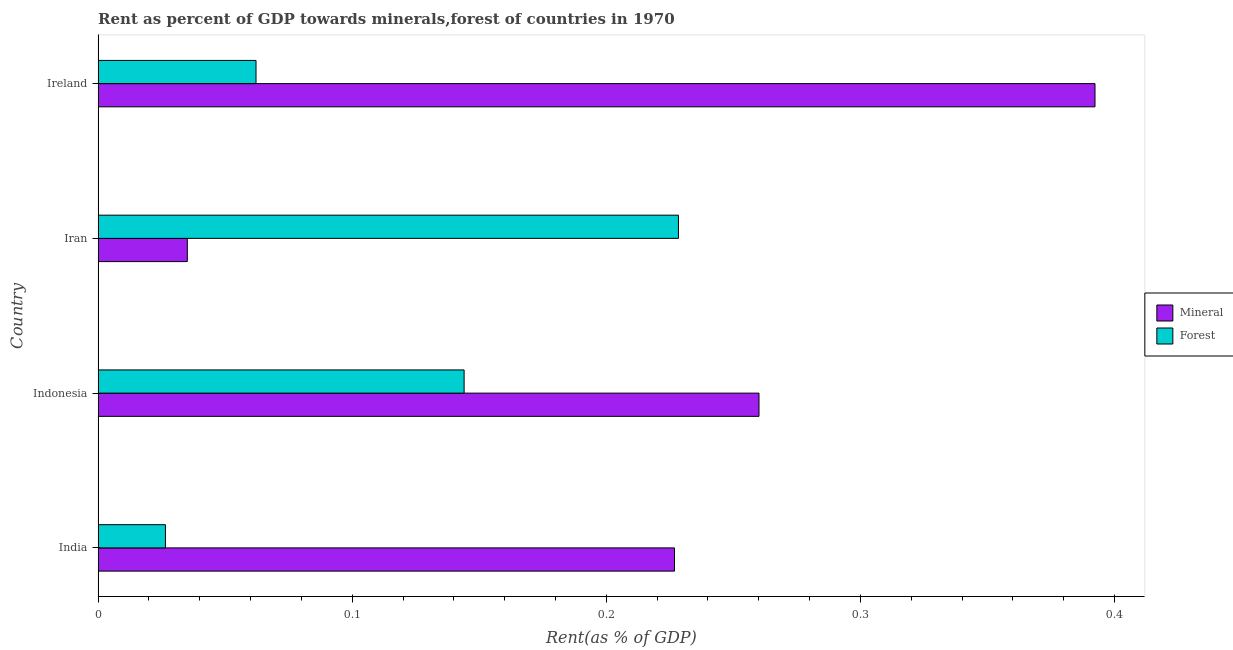Are the number of bars per tick equal to the number of legend labels?
Your answer should be very brief. Yes. How many bars are there on the 3rd tick from the top?
Your answer should be compact. 2. What is the label of the 4th group of bars from the top?
Offer a very short reply. India. In how many cases, is the number of bars for a given country not equal to the number of legend labels?
Offer a terse response. 0. What is the mineral rent in Indonesia?
Give a very brief answer. 0.26. Across all countries, what is the maximum mineral rent?
Your response must be concise. 0.39. Across all countries, what is the minimum forest rent?
Provide a succinct answer. 0.03. In which country was the mineral rent maximum?
Make the answer very short. Ireland. In which country was the forest rent minimum?
Provide a short and direct response. India. What is the total mineral rent in the graph?
Give a very brief answer. 0.91. What is the difference between the mineral rent in India and that in Ireland?
Offer a terse response. -0.17. What is the difference between the forest rent in Iran and the mineral rent in India?
Keep it short and to the point. 0. What is the average mineral rent per country?
Provide a short and direct response. 0.23. What is the difference between the mineral rent and forest rent in Indonesia?
Your answer should be very brief. 0.12. What is the ratio of the forest rent in India to that in Ireland?
Your response must be concise. 0.43. What is the difference between the highest and the second highest mineral rent?
Provide a short and direct response. 0.13. What is the difference between the highest and the lowest mineral rent?
Keep it short and to the point. 0.36. In how many countries, is the forest rent greater than the average forest rent taken over all countries?
Provide a short and direct response. 2. Is the sum of the mineral rent in India and Iran greater than the maximum forest rent across all countries?
Offer a very short reply. Yes. What does the 2nd bar from the top in India represents?
Ensure brevity in your answer.  Mineral. What does the 2nd bar from the bottom in Ireland represents?
Give a very brief answer. Forest. Are all the bars in the graph horizontal?
Make the answer very short. Yes. What is the difference between two consecutive major ticks on the X-axis?
Your response must be concise. 0.1. Are the values on the major ticks of X-axis written in scientific E-notation?
Keep it short and to the point. No. Does the graph contain any zero values?
Offer a terse response. No. Does the graph contain grids?
Give a very brief answer. No. How are the legend labels stacked?
Offer a very short reply. Vertical. What is the title of the graph?
Your answer should be very brief. Rent as percent of GDP towards minerals,forest of countries in 1970. What is the label or title of the X-axis?
Keep it short and to the point. Rent(as % of GDP). What is the Rent(as % of GDP) in Mineral in India?
Give a very brief answer. 0.23. What is the Rent(as % of GDP) in Forest in India?
Your answer should be compact. 0.03. What is the Rent(as % of GDP) of Mineral in Indonesia?
Offer a very short reply. 0.26. What is the Rent(as % of GDP) in Forest in Indonesia?
Offer a terse response. 0.14. What is the Rent(as % of GDP) of Mineral in Iran?
Ensure brevity in your answer.  0.04. What is the Rent(as % of GDP) of Forest in Iran?
Provide a succinct answer. 0.23. What is the Rent(as % of GDP) in Mineral in Ireland?
Your answer should be very brief. 0.39. What is the Rent(as % of GDP) in Forest in Ireland?
Make the answer very short. 0.06. Across all countries, what is the maximum Rent(as % of GDP) in Mineral?
Make the answer very short. 0.39. Across all countries, what is the maximum Rent(as % of GDP) of Forest?
Make the answer very short. 0.23. Across all countries, what is the minimum Rent(as % of GDP) in Mineral?
Offer a terse response. 0.04. Across all countries, what is the minimum Rent(as % of GDP) of Forest?
Offer a very short reply. 0.03. What is the total Rent(as % of GDP) of Mineral in the graph?
Your response must be concise. 0.91. What is the total Rent(as % of GDP) of Forest in the graph?
Make the answer very short. 0.46. What is the difference between the Rent(as % of GDP) in Mineral in India and that in Indonesia?
Give a very brief answer. -0.03. What is the difference between the Rent(as % of GDP) in Forest in India and that in Indonesia?
Provide a short and direct response. -0.12. What is the difference between the Rent(as % of GDP) in Mineral in India and that in Iran?
Ensure brevity in your answer.  0.19. What is the difference between the Rent(as % of GDP) in Forest in India and that in Iran?
Your response must be concise. -0.2. What is the difference between the Rent(as % of GDP) in Mineral in India and that in Ireland?
Your answer should be compact. -0.17. What is the difference between the Rent(as % of GDP) of Forest in India and that in Ireland?
Give a very brief answer. -0.04. What is the difference between the Rent(as % of GDP) of Mineral in Indonesia and that in Iran?
Your response must be concise. 0.23. What is the difference between the Rent(as % of GDP) of Forest in Indonesia and that in Iran?
Ensure brevity in your answer.  -0.08. What is the difference between the Rent(as % of GDP) of Mineral in Indonesia and that in Ireland?
Your answer should be compact. -0.13. What is the difference between the Rent(as % of GDP) of Forest in Indonesia and that in Ireland?
Offer a very short reply. 0.08. What is the difference between the Rent(as % of GDP) of Mineral in Iran and that in Ireland?
Keep it short and to the point. -0.36. What is the difference between the Rent(as % of GDP) in Forest in Iran and that in Ireland?
Keep it short and to the point. 0.17. What is the difference between the Rent(as % of GDP) of Mineral in India and the Rent(as % of GDP) of Forest in Indonesia?
Offer a very short reply. 0.08. What is the difference between the Rent(as % of GDP) in Mineral in India and the Rent(as % of GDP) in Forest in Iran?
Keep it short and to the point. -0. What is the difference between the Rent(as % of GDP) in Mineral in India and the Rent(as % of GDP) in Forest in Ireland?
Your answer should be very brief. 0.16. What is the difference between the Rent(as % of GDP) of Mineral in Indonesia and the Rent(as % of GDP) of Forest in Iran?
Provide a short and direct response. 0.03. What is the difference between the Rent(as % of GDP) in Mineral in Indonesia and the Rent(as % of GDP) in Forest in Ireland?
Keep it short and to the point. 0.2. What is the difference between the Rent(as % of GDP) of Mineral in Iran and the Rent(as % of GDP) of Forest in Ireland?
Ensure brevity in your answer.  -0.03. What is the average Rent(as % of GDP) in Mineral per country?
Offer a terse response. 0.23. What is the average Rent(as % of GDP) in Forest per country?
Ensure brevity in your answer.  0.12. What is the difference between the Rent(as % of GDP) of Mineral and Rent(as % of GDP) of Forest in India?
Offer a terse response. 0.2. What is the difference between the Rent(as % of GDP) of Mineral and Rent(as % of GDP) of Forest in Indonesia?
Your response must be concise. 0.12. What is the difference between the Rent(as % of GDP) in Mineral and Rent(as % of GDP) in Forest in Iran?
Ensure brevity in your answer.  -0.19. What is the difference between the Rent(as % of GDP) of Mineral and Rent(as % of GDP) of Forest in Ireland?
Your response must be concise. 0.33. What is the ratio of the Rent(as % of GDP) of Mineral in India to that in Indonesia?
Your response must be concise. 0.87. What is the ratio of the Rent(as % of GDP) in Forest in India to that in Indonesia?
Provide a short and direct response. 0.18. What is the ratio of the Rent(as % of GDP) of Mineral in India to that in Iran?
Offer a very short reply. 6.46. What is the ratio of the Rent(as % of GDP) in Forest in India to that in Iran?
Offer a terse response. 0.12. What is the ratio of the Rent(as % of GDP) of Mineral in India to that in Ireland?
Offer a terse response. 0.58. What is the ratio of the Rent(as % of GDP) in Forest in India to that in Ireland?
Make the answer very short. 0.43. What is the ratio of the Rent(as % of GDP) of Mineral in Indonesia to that in Iran?
Your answer should be very brief. 7.41. What is the ratio of the Rent(as % of GDP) in Forest in Indonesia to that in Iran?
Your answer should be compact. 0.63. What is the ratio of the Rent(as % of GDP) of Mineral in Indonesia to that in Ireland?
Keep it short and to the point. 0.66. What is the ratio of the Rent(as % of GDP) in Forest in Indonesia to that in Ireland?
Your answer should be compact. 2.32. What is the ratio of the Rent(as % of GDP) in Mineral in Iran to that in Ireland?
Provide a short and direct response. 0.09. What is the ratio of the Rent(as % of GDP) of Forest in Iran to that in Ireland?
Your answer should be very brief. 3.68. What is the difference between the highest and the second highest Rent(as % of GDP) of Mineral?
Your response must be concise. 0.13. What is the difference between the highest and the second highest Rent(as % of GDP) in Forest?
Offer a very short reply. 0.08. What is the difference between the highest and the lowest Rent(as % of GDP) in Mineral?
Offer a terse response. 0.36. What is the difference between the highest and the lowest Rent(as % of GDP) in Forest?
Offer a very short reply. 0.2. 